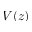Convert formula to latex. <formula><loc_0><loc_0><loc_500><loc_500>V ( z )</formula> 